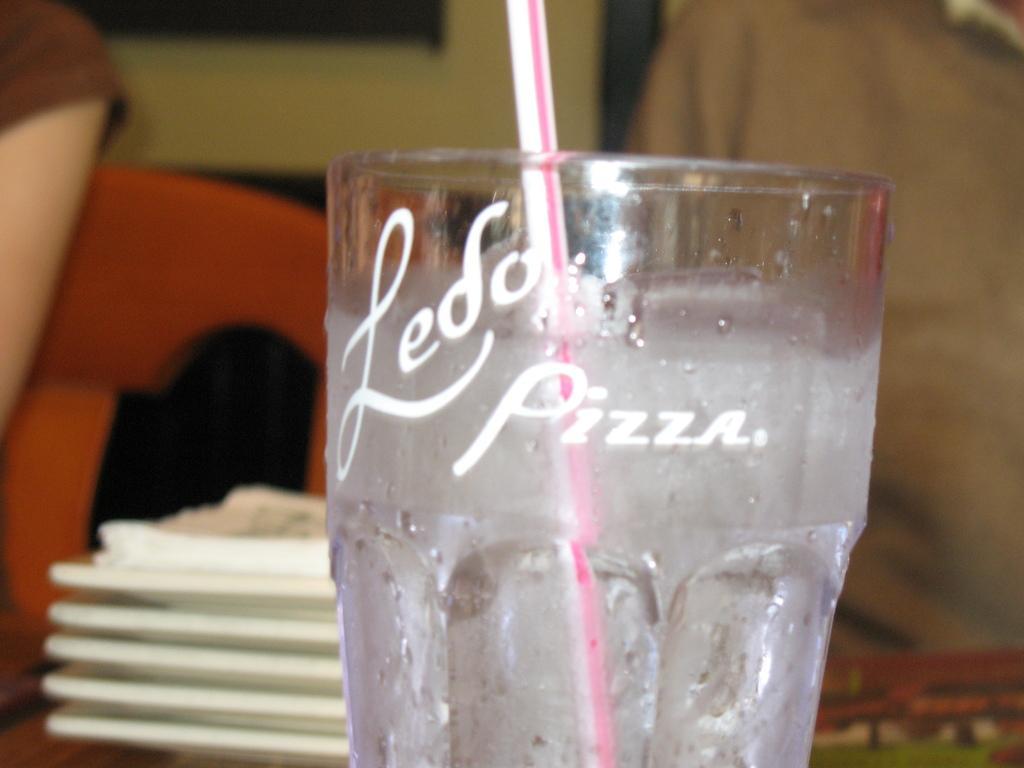Could you give a brief overview of what you see in this image? In this image I see a glass over here and I see a straw in it and I see something is written over here and it is blurred in the background and I see the white color things over here. 